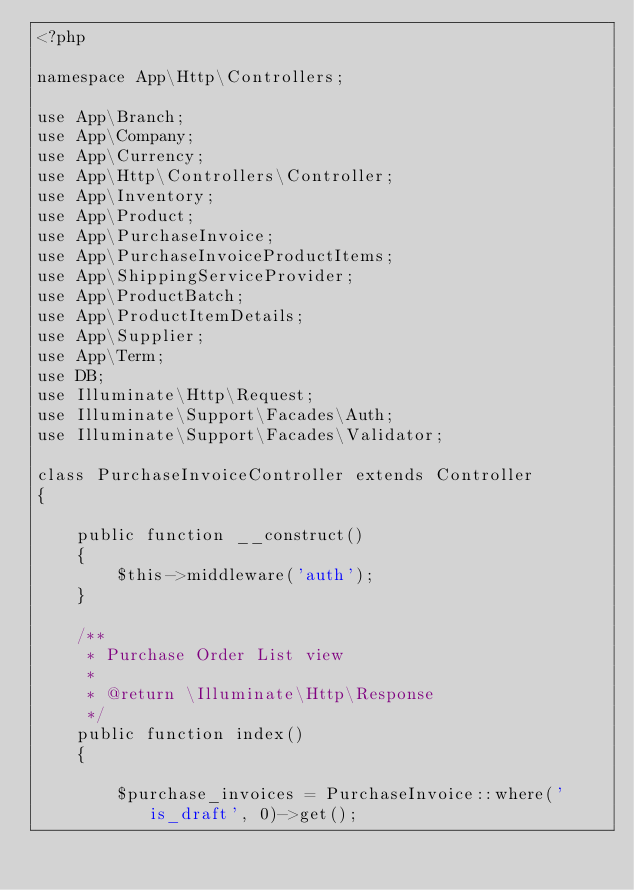Convert code to text. <code><loc_0><loc_0><loc_500><loc_500><_PHP_><?php

namespace App\Http\Controllers;

use App\Branch;
use App\Company;
use App\Currency;
use App\Http\Controllers\Controller;
use App\Inventory;
use App\Product;
use App\PurchaseInvoice;
use App\PurchaseInvoiceProductItems;
use App\ShippingServiceProvider;
use App\ProductBatch;
use App\ProductItemDetails;
use App\Supplier;
use App\Term;
use DB;
use Illuminate\Http\Request;
use Illuminate\Support\Facades\Auth;
use Illuminate\Support\Facades\Validator;

class PurchaseInvoiceController extends Controller
{

    public function __construct()
    {
        $this->middleware('auth');
    }

    /**
     * Purchase Order List view
     *
     * @return \Illuminate\Http\Response
     */
    public function index()
    {

        $purchase_invoices = PurchaseInvoice::where('is_draft', 0)->get();
</code> 